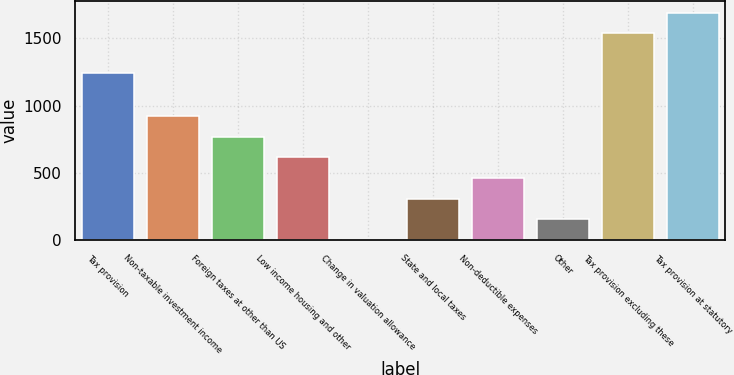<chart> <loc_0><loc_0><loc_500><loc_500><bar_chart><fcel>Tax provision<fcel>Non-taxable investment income<fcel>Foreign taxes at other than US<fcel>Low income housing and other<fcel>Change in valuation allowance<fcel>State and local taxes<fcel>Non-deductible expenses<fcel>Other<fcel>Tax provision excluding these<fcel>Tax provision at statutory<nl><fcel>1245<fcel>923.6<fcel>770<fcel>616.4<fcel>2<fcel>309.2<fcel>462.8<fcel>155.6<fcel>1538<fcel>1691.6<nl></chart> 